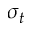<formula> <loc_0><loc_0><loc_500><loc_500>\sigma _ { t }</formula> 